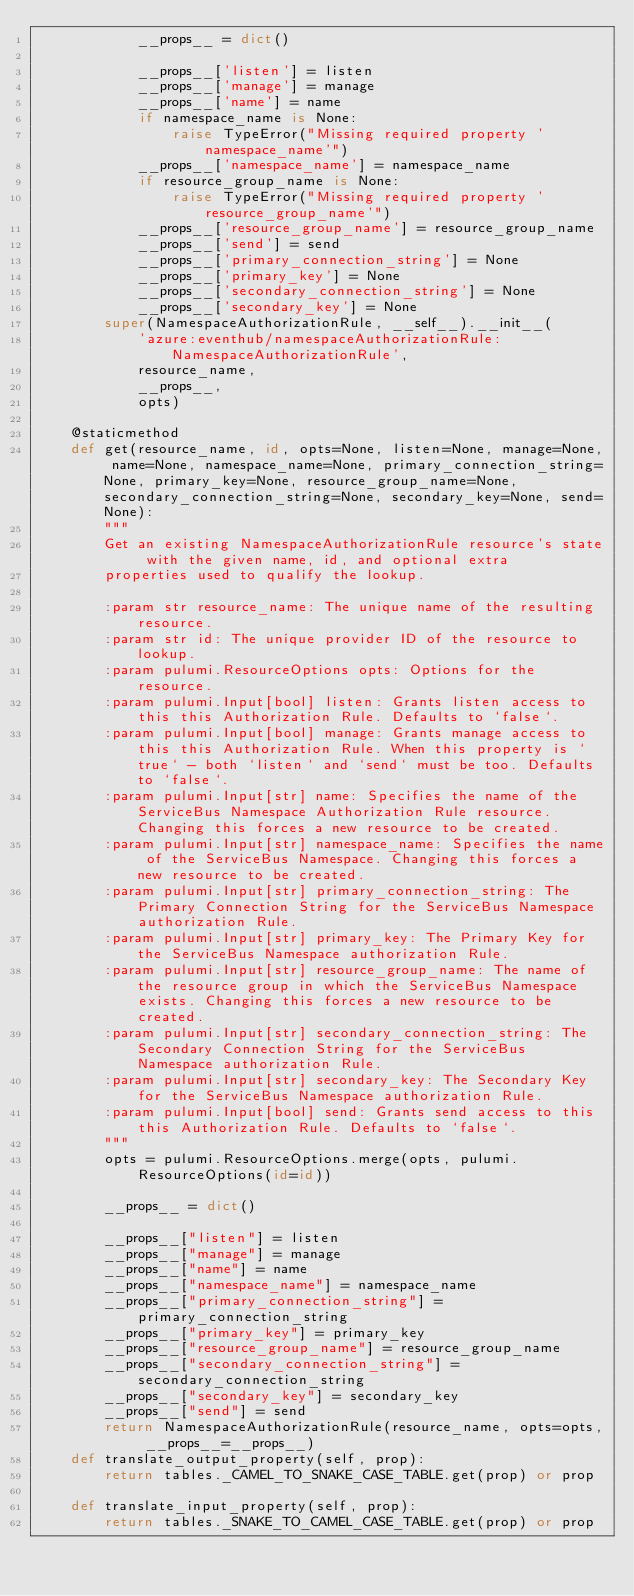Convert code to text. <code><loc_0><loc_0><loc_500><loc_500><_Python_>            __props__ = dict()

            __props__['listen'] = listen
            __props__['manage'] = manage
            __props__['name'] = name
            if namespace_name is None:
                raise TypeError("Missing required property 'namespace_name'")
            __props__['namespace_name'] = namespace_name
            if resource_group_name is None:
                raise TypeError("Missing required property 'resource_group_name'")
            __props__['resource_group_name'] = resource_group_name
            __props__['send'] = send
            __props__['primary_connection_string'] = None
            __props__['primary_key'] = None
            __props__['secondary_connection_string'] = None
            __props__['secondary_key'] = None
        super(NamespaceAuthorizationRule, __self__).__init__(
            'azure:eventhub/namespaceAuthorizationRule:NamespaceAuthorizationRule',
            resource_name,
            __props__,
            opts)

    @staticmethod
    def get(resource_name, id, opts=None, listen=None, manage=None, name=None, namespace_name=None, primary_connection_string=None, primary_key=None, resource_group_name=None, secondary_connection_string=None, secondary_key=None, send=None):
        """
        Get an existing NamespaceAuthorizationRule resource's state with the given name, id, and optional extra
        properties used to qualify the lookup.

        :param str resource_name: The unique name of the resulting resource.
        :param str id: The unique provider ID of the resource to lookup.
        :param pulumi.ResourceOptions opts: Options for the resource.
        :param pulumi.Input[bool] listen: Grants listen access to this this Authorization Rule. Defaults to `false`.
        :param pulumi.Input[bool] manage: Grants manage access to this this Authorization Rule. When this property is `true` - both `listen` and `send` must be too. Defaults to `false`.
        :param pulumi.Input[str] name: Specifies the name of the ServiceBus Namespace Authorization Rule resource. Changing this forces a new resource to be created.
        :param pulumi.Input[str] namespace_name: Specifies the name of the ServiceBus Namespace. Changing this forces a new resource to be created.
        :param pulumi.Input[str] primary_connection_string: The Primary Connection String for the ServiceBus Namespace authorization Rule.
        :param pulumi.Input[str] primary_key: The Primary Key for the ServiceBus Namespace authorization Rule.
        :param pulumi.Input[str] resource_group_name: The name of the resource group in which the ServiceBus Namespace exists. Changing this forces a new resource to be created.
        :param pulumi.Input[str] secondary_connection_string: The Secondary Connection String for the ServiceBus Namespace authorization Rule.
        :param pulumi.Input[str] secondary_key: The Secondary Key for the ServiceBus Namespace authorization Rule.
        :param pulumi.Input[bool] send: Grants send access to this this Authorization Rule. Defaults to `false`.
        """
        opts = pulumi.ResourceOptions.merge(opts, pulumi.ResourceOptions(id=id))

        __props__ = dict()

        __props__["listen"] = listen
        __props__["manage"] = manage
        __props__["name"] = name
        __props__["namespace_name"] = namespace_name
        __props__["primary_connection_string"] = primary_connection_string
        __props__["primary_key"] = primary_key
        __props__["resource_group_name"] = resource_group_name
        __props__["secondary_connection_string"] = secondary_connection_string
        __props__["secondary_key"] = secondary_key
        __props__["send"] = send
        return NamespaceAuthorizationRule(resource_name, opts=opts, __props__=__props__)
    def translate_output_property(self, prop):
        return tables._CAMEL_TO_SNAKE_CASE_TABLE.get(prop) or prop

    def translate_input_property(self, prop):
        return tables._SNAKE_TO_CAMEL_CASE_TABLE.get(prop) or prop

</code> 